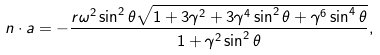Convert formula to latex. <formula><loc_0><loc_0><loc_500><loc_500>n \cdot a = - { \frac { r { \omega } ^ { 2 } \sin ^ { 2 } \theta \sqrt { 1 + 3 \gamma ^ { 2 } + 3 \gamma ^ { 4 } \sin ^ { 2 } \theta + \gamma ^ { 6 } \sin ^ { 4 } \theta } } { 1 + \gamma ^ { 2 } \sin ^ { 2 } \theta } } ,</formula> 